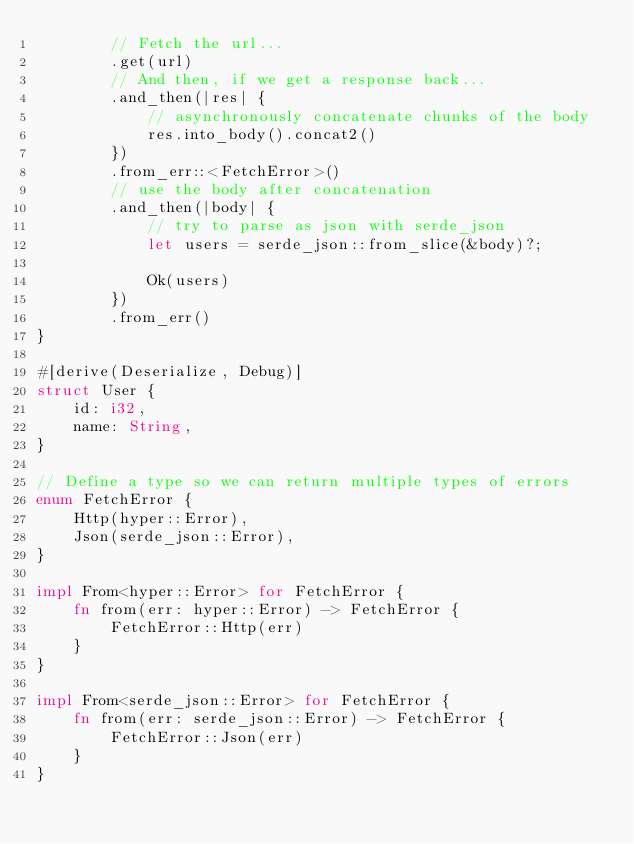<code> <loc_0><loc_0><loc_500><loc_500><_Rust_>        // Fetch the url...
        .get(url)
        // And then, if we get a response back...
        .and_then(|res| {
            // asynchronously concatenate chunks of the body
            res.into_body().concat2()
        })
        .from_err::<FetchError>()
        // use the body after concatenation
        .and_then(|body| {
            // try to parse as json with serde_json
            let users = serde_json::from_slice(&body)?;

            Ok(users)
        })
        .from_err()
}

#[derive(Deserialize, Debug)]
struct User {
    id: i32,
    name: String,
}

// Define a type so we can return multiple types of errors
enum FetchError {
    Http(hyper::Error),
    Json(serde_json::Error),
}

impl From<hyper::Error> for FetchError {
    fn from(err: hyper::Error) -> FetchError {
        FetchError::Http(err)
    }
}

impl From<serde_json::Error> for FetchError {
    fn from(err: serde_json::Error) -> FetchError {
        FetchError::Json(err)
    }
}
</code> 